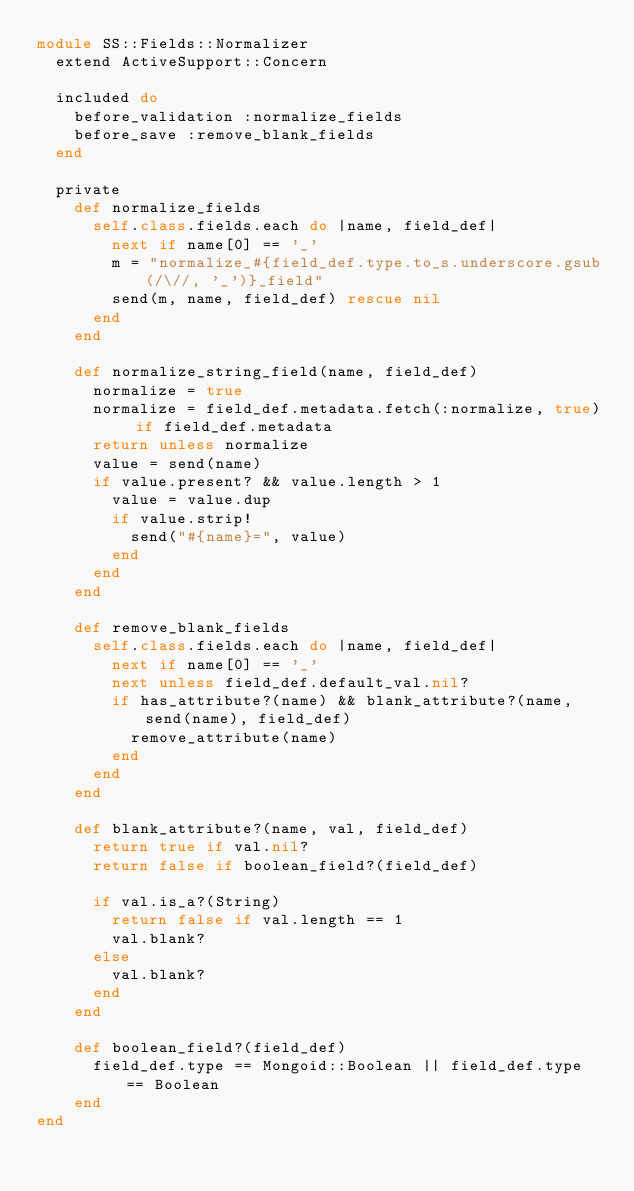Convert code to text. <code><loc_0><loc_0><loc_500><loc_500><_Ruby_>module SS::Fields::Normalizer
  extend ActiveSupport::Concern

  included do
    before_validation :normalize_fields
    before_save :remove_blank_fields
  end

  private
    def normalize_fields
      self.class.fields.each do |name, field_def|
        next if name[0] == '_'
        m = "normalize_#{field_def.type.to_s.underscore.gsub(/\//, '_')}_field"
        send(m, name, field_def) rescue nil
      end
    end

    def normalize_string_field(name, field_def)
      normalize = true
      normalize = field_def.metadata.fetch(:normalize, true) if field_def.metadata
      return unless normalize
      value = send(name)
      if value.present? && value.length > 1
        value = value.dup
        if value.strip!
          send("#{name}=", value)
        end
      end
    end

    def remove_blank_fields
      self.class.fields.each do |name, field_def|
        next if name[0] == '_'
        next unless field_def.default_val.nil?
        if has_attribute?(name) && blank_attribute?(name, send(name), field_def)
          remove_attribute(name)
        end
      end
    end

    def blank_attribute?(name, val, field_def)
      return true if val.nil?
      return false if boolean_field?(field_def)

      if val.is_a?(String)
        return false if val.length == 1
        val.blank?
      else
        val.blank?
      end
    end

    def boolean_field?(field_def)
      field_def.type == Mongoid::Boolean || field_def.type == Boolean
    end
end
</code> 